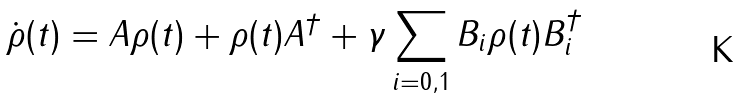Convert formula to latex. <formula><loc_0><loc_0><loc_500><loc_500>\dot { \rho } ( t ) = A \rho ( t ) + \rho ( t ) A ^ { \dag } + \gamma \sum _ { i = 0 , 1 } B _ { i } \rho ( t ) B _ { i } ^ { \dag }</formula> 